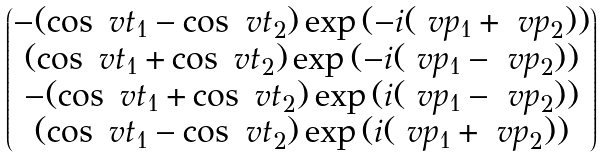<formula> <loc_0><loc_0><loc_500><loc_500>\begin{pmatrix} - ( \cos \ v t _ { 1 } - \cos \ v t _ { 2 } ) \exp { ( - i ( \ v p _ { 1 } + \ v p _ { 2 } ) ) } \\ ( \cos \ v t _ { 1 } + \cos \ v t _ { 2 } ) \exp { ( - i ( \ v p _ { 1 } - \ v p _ { 2 } ) ) } \\ - ( \cos \ v t _ { 1 } + \cos \ v t _ { 2 } ) \exp { ( i ( \ v p _ { 1 } - \ v p _ { 2 } ) ) } \\ ( \cos \ v t _ { 1 } - \cos \ v t _ { 2 } ) \exp { ( i ( \ v p _ { 1 } + \ v p _ { 2 } ) ) } \\ \end{pmatrix}</formula> 